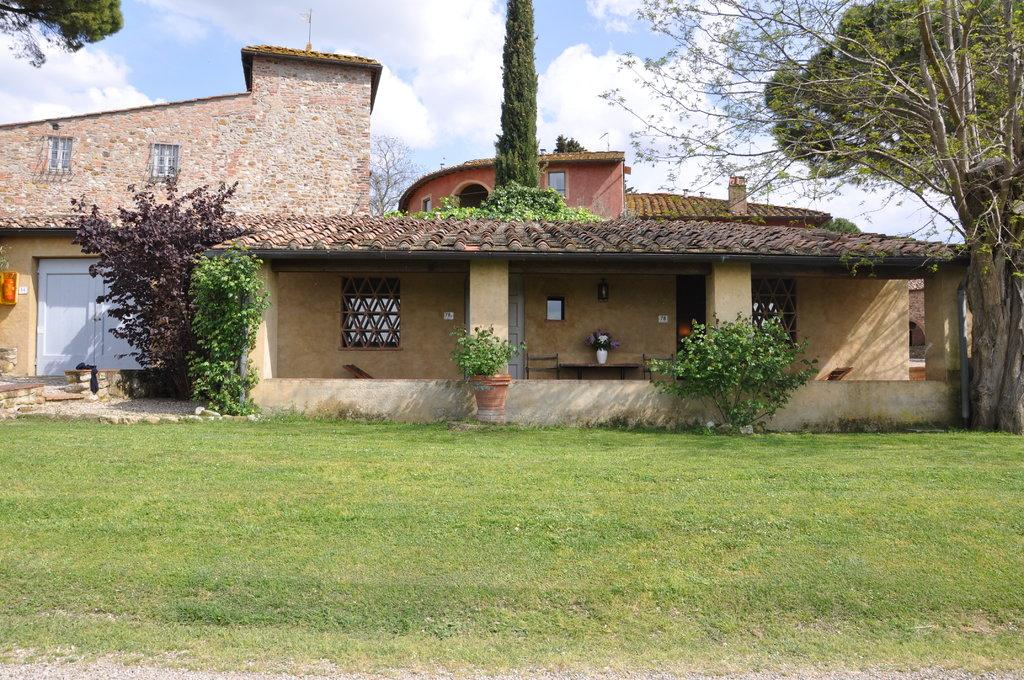What type of structure is in the image? There is a building in the image. What is located in front of the building? The building has a garden in front of it. What can be seen on either side of the garden? There are plants on either side of the garden. What is visible in the background of the image? The sky is visible in the image. What can be observed in the sky? Clouds are present in the sky. What type of record can be seen spinning on the roof of the building in the image? There is no record present in the image, and the roof of the building is not visible. 